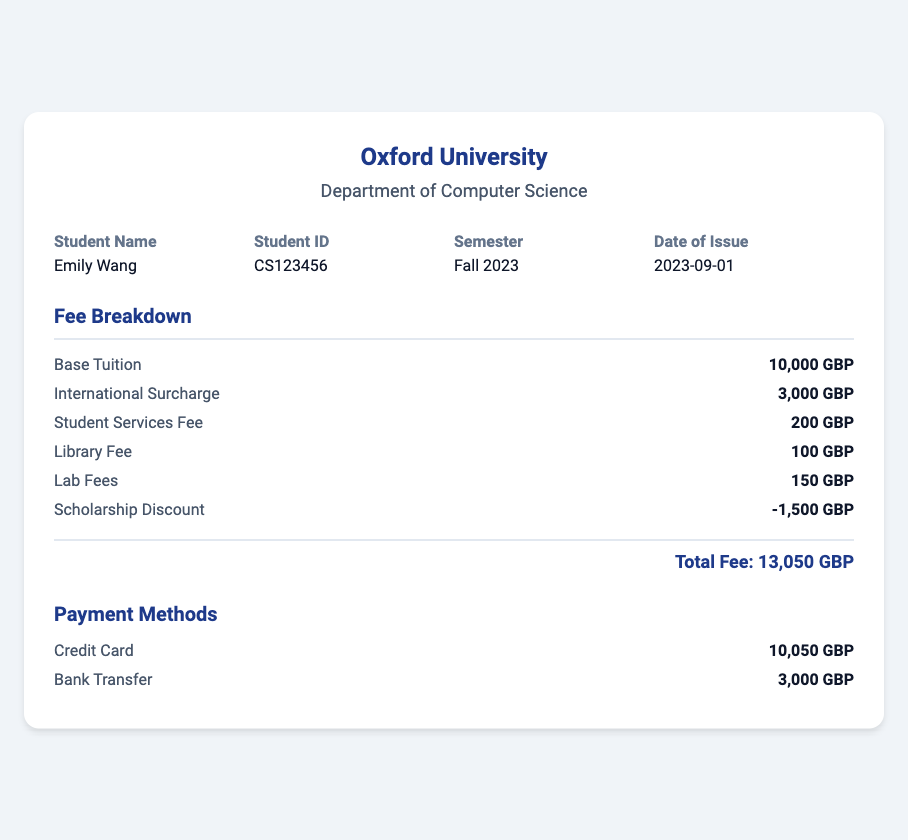What is the university name? The university name is prominently displayed at the top of the document and is "Oxford University."
Answer: Oxford University What is the student ID? The student ID is located in the student info section and is displayed as "CS123456."
Answer: CS123456 What is the total fee for the semester? The total fee is calculated as shown at the end of the fee breakdown, which totals "13,050 GBP."
Answer: 13,050 GBP What is the amount of the international surcharge? This fee is specified in the fee breakdown as "3,000 GBP."
Answer: 3,000 GBP How much is the scholarship discount? The scholarship discount is mentioned in the fee breakdown and is "1,500 GBP."
Answer: -1,500 GBP What payment method was used for the majority of the payment? The payment method breakdown indicates that "Credit Card" was used for the larger sum.
Answer: Credit Card What is the date of issue for the receipt? The date of issue is clearly stated in the student info section and is "2023-09-01."
Answer: 2023-09-01 How many fees are listed in the breakdown? The breakdown lists a total of six fees, including the scholarship discount.
Answer: 6 What is the amount for the library fee? The library fee is detailed in the fee breakdown and is "100 GBP."
Answer: 100 GBP Which semester is this receipt for? The semester is indicated in the student info section as "Fall 2023."
Answer: Fall 2023 